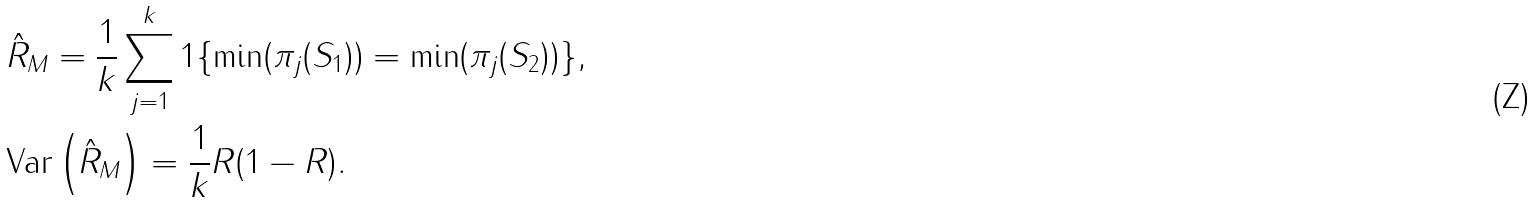<formula> <loc_0><loc_0><loc_500><loc_500>& \hat { R } _ { M } = \frac { 1 } { k } \sum _ { j = 1 } ^ { k } 1 \{ { \min } ( { \pi _ { j } } ( S _ { 1 } ) ) = { \min } ( { \pi _ { j } } ( S _ { 2 } ) ) \} , \\ & \text {Var} \left ( \hat { R } _ { M } \right ) = \frac { 1 } { k } R ( 1 - R ) .</formula> 